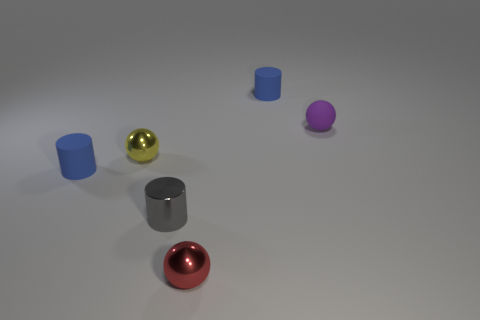Can we discern any source of lighting in the scene? There is no direct source of lighting visible, but the shadows cast and the soft lighting suggest an environment with ambient, diffused light, possibly from an overhead source. 